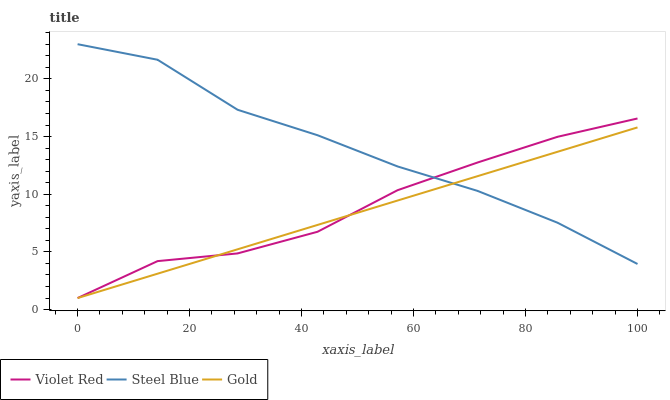Does Gold have the minimum area under the curve?
Answer yes or no. Yes. Does Steel Blue have the maximum area under the curve?
Answer yes or no. Yes. Does Steel Blue have the minimum area under the curve?
Answer yes or no. No. Does Gold have the maximum area under the curve?
Answer yes or no. No. Is Gold the smoothest?
Answer yes or no. Yes. Is Steel Blue the roughest?
Answer yes or no. Yes. Is Steel Blue the smoothest?
Answer yes or no. No. Is Gold the roughest?
Answer yes or no. No. Does Violet Red have the lowest value?
Answer yes or no. Yes. Does Steel Blue have the lowest value?
Answer yes or no. No. Does Steel Blue have the highest value?
Answer yes or no. Yes. Does Gold have the highest value?
Answer yes or no. No. Does Steel Blue intersect Gold?
Answer yes or no. Yes. Is Steel Blue less than Gold?
Answer yes or no. No. Is Steel Blue greater than Gold?
Answer yes or no. No. 